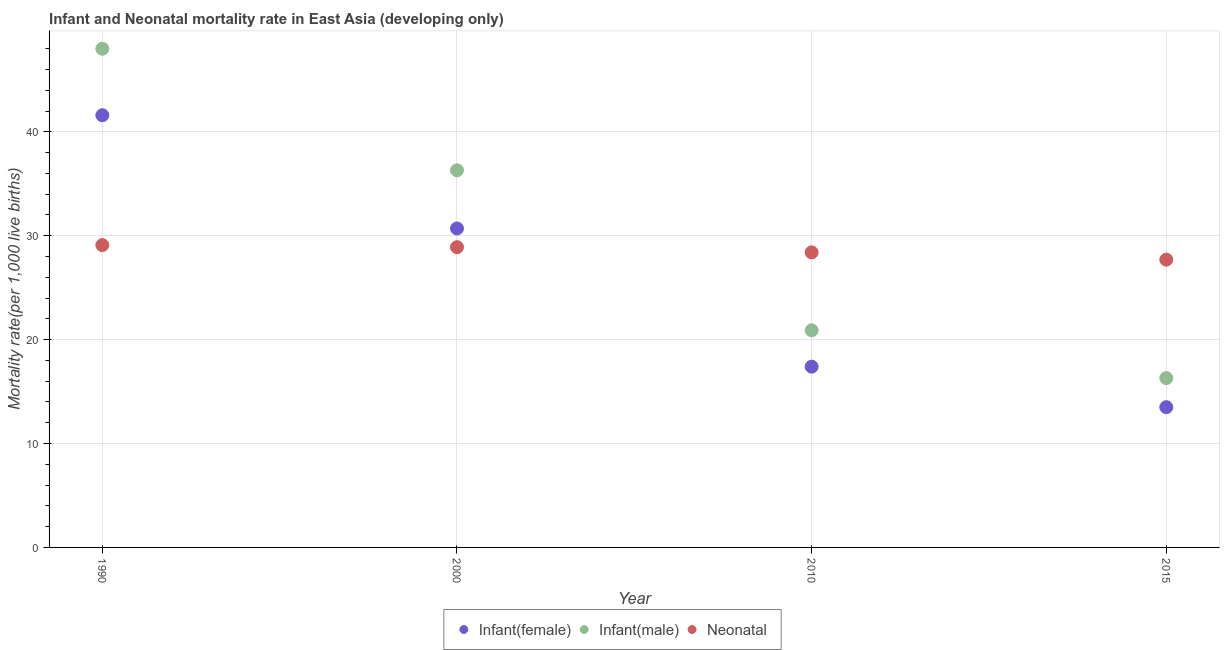What is the infant mortality rate(male) in 2000?
Give a very brief answer. 36.3. Across all years, what is the maximum neonatal mortality rate?
Ensure brevity in your answer.  29.1. Across all years, what is the minimum neonatal mortality rate?
Provide a short and direct response. 27.7. In which year was the neonatal mortality rate maximum?
Make the answer very short. 1990. In which year was the infant mortality rate(male) minimum?
Provide a short and direct response. 2015. What is the total neonatal mortality rate in the graph?
Offer a very short reply. 114.1. What is the difference between the infant mortality rate(female) in 2010 and that in 2015?
Your answer should be compact. 3.9. What is the difference between the infant mortality rate(female) in 1990 and the infant mortality rate(male) in 2000?
Give a very brief answer. 5.3. What is the average infant mortality rate(female) per year?
Your answer should be compact. 25.8. In the year 2015, what is the difference between the infant mortality rate(female) and neonatal mortality rate?
Your answer should be very brief. -14.2. What is the ratio of the neonatal mortality rate in 1990 to that in 2010?
Provide a succinct answer. 1.02. Is the neonatal mortality rate in 2000 less than that in 2015?
Your answer should be compact. No. What is the difference between the highest and the second highest neonatal mortality rate?
Offer a very short reply. 0.2. What is the difference between the highest and the lowest neonatal mortality rate?
Your answer should be compact. 1.4. Is the sum of the infant mortality rate(male) in 2000 and 2010 greater than the maximum neonatal mortality rate across all years?
Make the answer very short. Yes. Does the neonatal mortality rate monotonically increase over the years?
Your answer should be very brief. No. Is the neonatal mortality rate strictly less than the infant mortality rate(male) over the years?
Keep it short and to the point. No. What is the difference between two consecutive major ticks on the Y-axis?
Provide a short and direct response. 10. Does the graph contain any zero values?
Offer a terse response. No. Where does the legend appear in the graph?
Your response must be concise. Bottom center. How many legend labels are there?
Your answer should be compact. 3. How are the legend labels stacked?
Your answer should be very brief. Horizontal. What is the title of the graph?
Ensure brevity in your answer.  Infant and Neonatal mortality rate in East Asia (developing only). Does "Private sector" appear as one of the legend labels in the graph?
Ensure brevity in your answer.  No. What is the label or title of the Y-axis?
Your answer should be very brief. Mortality rate(per 1,0 live births). What is the Mortality rate(per 1,000 live births) of Infant(female) in 1990?
Provide a succinct answer. 41.6. What is the Mortality rate(per 1,000 live births) in Neonatal  in 1990?
Provide a short and direct response. 29.1. What is the Mortality rate(per 1,000 live births) in Infant(female) in 2000?
Give a very brief answer. 30.7. What is the Mortality rate(per 1,000 live births) of Infant(male) in 2000?
Provide a succinct answer. 36.3. What is the Mortality rate(per 1,000 live births) of Neonatal  in 2000?
Your answer should be very brief. 28.9. What is the Mortality rate(per 1,000 live births) in Infant(male) in 2010?
Offer a very short reply. 20.9. What is the Mortality rate(per 1,000 live births) in Neonatal  in 2010?
Keep it short and to the point. 28.4. What is the Mortality rate(per 1,000 live births) of Infant(female) in 2015?
Your answer should be compact. 13.5. What is the Mortality rate(per 1,000 live births) in Infant(male) in 2015?
Your answer should be very brief. 16.3. What is the Mortality rate(per 1,000 live births) of Neonatal  in 2015?
Make the answer very short. 27.7. Across all years, what is the maximum Mortality rate(per 1,000 live births) in Infant(female)?
Provide a short and direct response. 41.6. Across all years, what is the maximum Mortality rate(per 1,000 live births) of Neonatal ?
Your answer should be very brief. 29.1. Across all years, what is the minimum Mortality rate(per 1,000 live births) of Infant(male)?
Your answer should be compact. 16.3. Across all years, what is the minimum Mortality rate(per 1,000 live births) in Neonatal ?
Give a very brief answer. 27.7. What is the total Mortality rate(per 1,000 live births) of Infant(female) in the graph?
Provide a short and direct response. 103.2. What is the total Mortality rate(per 1,000 live births) in Infant(male) in the graph?
Offer a very short reply. 121.5. What is the total Mortality rate(per 1,000 live births) of Neonatal  in the graph?
Make the answer very short. 114.1. What is the difference between the Mortality rate(per 1,000 live births) of Infant(male) in 1990 and that in 2000?
Offer a very short reply. 11.7. What is the difference between the Mortality rate(per 1,000 live births) of Infant(female) in 1990 and that in 2010?
Give a very brief answer. 24.2. What is the difference between the Mortality rate(per 1,000 live births) in Infant(male) in 1990 and that in 2010?
Keep it short and to the point. 27.1. What is the difference between the Mortality rate(per 1,000 live births) of Neonatal  in 1990 and that in 2010?
Your answer should be compact. 0.7. What is the difference between the Mortality rate(per 1,000 live births) in Infant(female) in 1990 and that in 2015?
Your response must be concise. 28.1. What is the difference between the Mortality rate(per 1,000 live births) of Infant(male) in 1990 and that in 2015?
Give a very brief answer. 31.7. What is the difference between the Mortality rate(per 1,000 live births) in Infant(female) in 2000 and that in 2010?
Your answer should be compact. 13.3. What is the difference between the Mortality rate(per 1,000 live births) of Infant(male) in 2000 and that in 2010?
Offer a very short reply. 15.4. What is the difference between the Mortality rate(per 1,000 live births) in Infant(female) in 2000 and that in 2015?
Keep it short and to the point. 17.2. What is the difference between the Mortality rate(per 1,000 live births) of Infant(male) in 2000 and that in 2015?
Ensure brevity in your answer.  20. What is the difference between the Mortality rate(per 1,000 live births) in Infant(male) in 2010 and that in 2015?
Your answer should be very brief. 4.6. What is the difference between the Mortality rate(per 1,000 live births) of Neonatal  in 2010 and that in 2015?
Offer a terse response. 0.7. What is the difference between the Mortality rate(per 1,000 live births) in Infant(female) in 1990 and the Mortality rate(per 1,000 live births) in Infant(male) in 2000?
Ensure brevity in your answer.  5.3. What is the difference between the Mortality rate(per 1,000 live births) of Infant(female) in 1990 and the Mortality rate(per 1,000 live births) of Neonatal  in 2000?
Offer a terse response. 12.7. What is the difference between the Mortality rate(per 1,000 live births) of Infant(male) in 1990 and the Mortality rate(per 1,000 live births) of Neonatal  in 2000?
Provide a short and direct response. 19.1. What is the difference between the Mortality rate(per 1,000 live births) of Infant(female) in 1990 and the Mortality rate(per 1,000 live births) of Infant(male) in 2010?
Your answer should be very brief. 20.7. What is the difference between the Mortality rate(per 1,000 live births) in Infant(male) in 1990 and the Mortality rate(per 1,000 live births) in Neonatal  in 2010?
Your response must be concise. 19.6. What is the difference between the Mortality rate(per 1,000 live births) in Infant(female) in 1990 and the Mortality rate(per 1,000 live births) in Infant(male) in 2015?
Your answer should be very brief. 25.3. What is the difference between the Mortality rate(per 1,000 live births) of Infant(male) in 1990 and the Mortality rate(per 1,000 live births) of Neonatal  in 2015?
Your answer should be very brief. 20.3. What is the difference between the Mortality rate(per 1,000 live births) of Infant(female) in 2000 and the Mortality rate(per 1,000 live births) of Neonatal  in 2010?
Provide a short and direct response. 2.3. What is the average Mortality rate(per 1,000 live births) of Infant(female) per year?
Make the answer very short. 25.8. What is the average Mortality rate(per 1,000 live births) in Infant(male) per year?
Keep it short and to the point. 30.38. What is the average Mortality rate(per 1,000 live births) in Neonatal  per year?
Your answer should be very brief. 28.52. In the year 1990, what is the difference between the Mortality rate(per 1,000 live births) in Infant(female) and Mortality rate(per 1,000 live births) in Neonatal ?
Make the answer very short. 12.5. In the year 2000, what is the difference between the Mortality rate(per 1,000 live births) in Infant(female) and Mortality rate(per 1,000 live births) in Infant(male)?
Make the answer very short. -5.6. In the year 2000, what is the difference between the Mortality rate(per 1,000 live births) of Infant(female) and Mortality rate(per 1,000 live births) of Neonatal ?
Your answer should be compact. 1.8. In the year 2010, what is the difference between the Mortality rate(per 1,000 live births) of Infant(female) and Mortality rate(per 1,000 live births) of Neonatal ?
Offer a terse response. -11. In the year 2015, what is the difference between the Mortality rate(per 1,000 live births) of Infant(female) and Mortality rate(per 1,000 live births) of Neonatal ?
Make the answer very short. -14.2. What is the ratio of the Mortality rate(per 1,000 live births) in Infant(female) in 1990 to that in 2000?
Offer a terse response. 1.35. What is the ratio of the Mortality rate(per 1,000 live births) in Infant(male) in 1990 to that in 2000?
Offer a very short reply. 1.32. What is the ratio of the Mortality rate(per 1,000 live births) of Neonatal  in 1990 to that in 2000?
Offer a very short reply. 1.01. What is the ratio of the Mortality rate(per 1,000 live births) of Infant(female) in 1990 to that in 2010?
Make the answer very short. 2.39. What is the ratio of the Mortality rate(per 1,000 live births) of Infant(male) in 1990 to that in 2010?
Your answer should be compact. 2.3. What is the ratio of the Mortality rate(per 1,000 live births) of Neonatal  in 1990 to that in 2010?
Provide a succinct answer. 1.02. What is the ratio of the Mortality rate(per 1,000 live births) in Infant(female) in 1990 to that in 2015?
Keep it short and to the point. 3.08. What is the ratio of the Mortality rate(per 1,000 live births) in Infant(male) in 1990 to that in 2015?
Offer a terse response. 2.94. What is the ratio of the Mortality rate(per 1,000 live births) of Neonatal  in 1990 to that in 2015?
Ensure brevity in your answer.  1.05. What is the ratio of the Mortality rate(per 1,000 live births) of Infant(female) in 2000 to that in 2010?
Keep it short and to the point. 1.76. What is the ratio of the Mortality rate(per 1,000 live births) in Infant(male) in 2000 to that in 2010?
Your answer should be compact. 1.74. What is the ratio of the Mortality rate(per 1,000 live births) of Neonatal  in 2000 to that in 2010?
Offer a terse response. 1.02. What is the ratio of the Mortality rate(per 1,000 live births) of Infant(female) in 2000 to that in 2015?
Offer a terse response. 2.27. What is the ratio of the Mortality rate(per 1,000 live births) of Infant(male) in 2000 to that in 2015?
Provide a short and direct response. 2.23. What is the ratio of the Mortality rate(per 1,000 live births) in Neonatal  in 2000 to that in 2015?
Keep it short and to the point. 1.04. What is the ratio of the Mortality rate(per 1,000 live births) in Infant(female) in 2010 to that in 2015?
Offer a very short reply. 1.29. What is the ratio of the Mortality rate(per 1,000 live births) in Infant(male) in 2010 to that in 2015?
Give a very brief answer. 1.28. What is the ratio of the Mortality rate(per 1,000 live births) of Neonatal  in 2010 to that in 2015?
Ensure brevity in your answer.  1.03. What is the difference between the highest and the lowest Mortality rate(per 1,000 live births) in Infant(female)?
Ensure brevity in your answer.  28.1. What is the difference between the highest and the lowest Mortality rate(per 1,000 live births) of Infant(male)?
Offer a terse response. 31.7. 